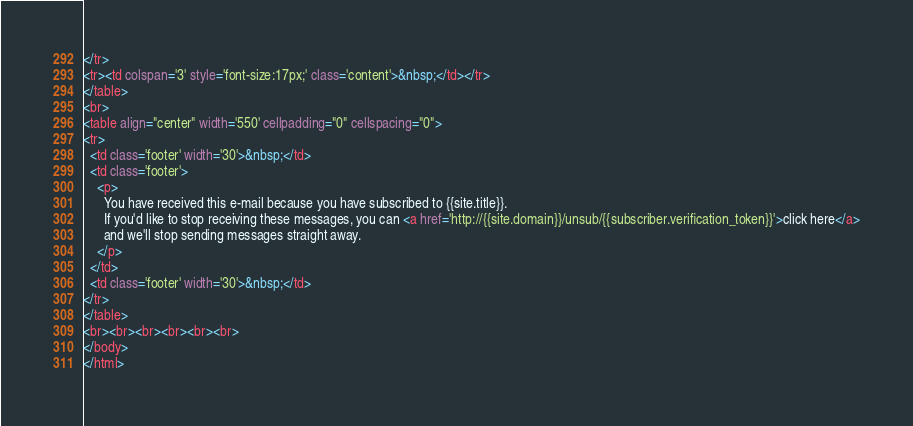<code> <loc_0><loc_0><loc_500><loc_500><_HTML_></tr>
<tr><td colspan='3' style='font-size:17px;' class='content'>&nbsp;</td></tr>
</table>
<br>
<table align="center" width='550' cellpadding="0" cellspacing="0">
<tr>
  <td class='footer' width='30'>&nbsp;</td>
  <td class='footer'>
    <p>
      You have received this e-mail because you have subscribed to {{site.title}}.
      If you'd like to stop receiving these messages, you can <a href='http://{{site.domain}}/unsub/{{subscriber.verification_token}}'>click here</a>
      and we'll stop sending messages straight away.
    </p>
  </td>
  <td class='footer' width='30'>&nbsp;</td>
</tr>
</table>
<br><br><br><br><br><br>
</body>
</html>
</code> 